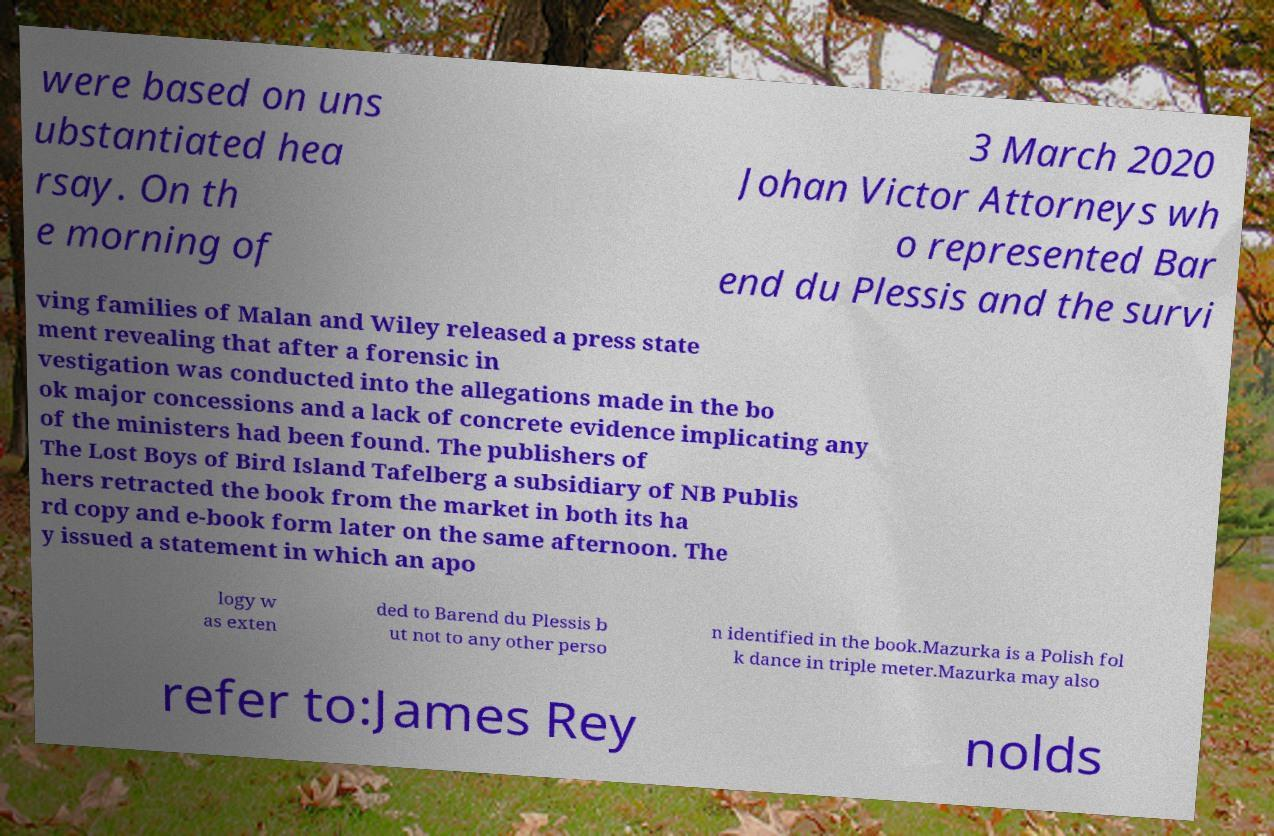For documentation purposes, I need the text within this image transcribed. Could you provide that? were based on uns ubstantiated hea rsay. On th e morning of 3 March 2020 Johan Victor Attorneys wh o represented Bar end du Plessis and the survi ving families of Malan and Wiley released a press state ment revealing that after a forensic in vestigation was conducted into the allegations made in the bo ok major concessions and a lack of concrete evidence implicating any of the ministers had been found. The publishers of The Lost Boys of Bird Island Tafelberg a subsidiary of NB Publis hers retracted the book from the market in both its ha rd copy and e-book form later on the same afternoon. The y issued a statement in which an apo logy w as exten ded to Barend du Plessis b ut not to any other perso n identified in the book.Mazurka is a Polish fol k dance in triple meter.Mazurka may also refer to:James Rey nolds 